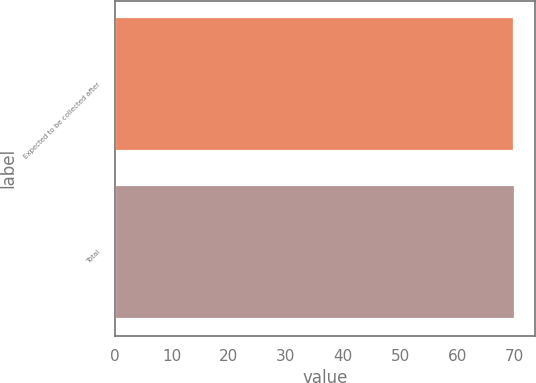Convert chart to OTSL. <chart><loc_0><loc_0><loc_500><loc_500><bar_chart><fcel>Expected to be collected after<fcel>Total<nl><fcel>70<fcel>70.1<nl></chart> 